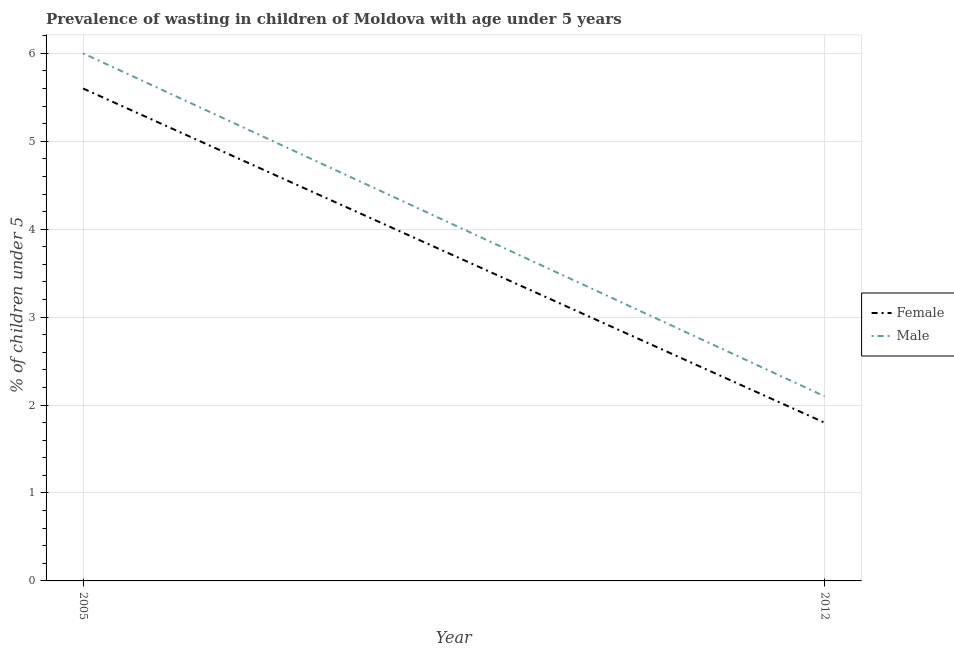Is the number of lines equal to the number of legend labels?
Offer a terse response. Yes. What is the percentage of undernourished female children in 2012?
Ensure brevity in your answer.  1.8. Across all years, what is the maximum percentage of undernourished female children?
Your answer should be compact. 5.6. Across all years, what is the minimum percentage of undernourished female children?
Your answer should be compact. 1.8. In which year was the percentage of undernourished female children maximum?
Make the answer very short. 2005. In which year was the percentage of undernourished male children minimum?
Your answer should be very brief. 2012. What is the total percentage of undernourished male children in the graph?
Give a very brief answer. 8.1. What is the difference between the percentage of undernourished male children in 2005 and that in 2012?
Keep it short and to the point. 3.9. What is the difference between the percentage of undernourished female children in 2005 and the percentage of undernourished male children in 2012?
Provide a succinct answer. 3.5. What is the average percentage of undernourished male children per year?
Ensure brevity in your answer.  4.05. In the year 2005, what is the difference between the percentage of undernourished male children and percentage of undernourished female children?
Keep it short and to the point. 0.4. In how many years, is the percentage of undernourished female children greater than 0.8 %?
Keep it short and to the point. 2. What is the ratio of the percentage of undernourished male children in 2005 to that in 2012?
Your answer should be compact. 2.86. Is the percentage of undernourished male children in 2005 less than that in 2012?
Your answer should be very brief. No. In how many years, is the percentage of undernourished female children greater than the average percentage of undernourished female children taken over all years?
Ensure brevity in your answer.  1. Is the percentage of undernourished female children strictly less than the percentage of undernourished male children over the years?
Your response must be concise. Yes. How many years are there in the graph?
Your answer should be very brief. 2. What is the difference between two consecutive major ticks on the Y-axis?
Make the answer very short. 1. Are the values on the major ticks of Y-axis written in scientific E-notation?
Keep it short and to the point. No. Does the graph contain any zero values?
Your answer should be very brief. No. Where does the legend appear in the graph?
Make the answer very short. Center right. How many legend labels are there?
Your response must be concise. 2. How are the legend labels stacked?
Your answer should be compact. Vertical. What is the title of the graph?
Offer a terse response. Prevalence of wasting in children of Moldova with age under 5 years. What is the label or title of the X-axis?
Make the answer very short. Year. What is the label or title of the Y-axis?
Your answer should be compact.  % of children under 5. What is the  % of children under 5 in Female in 2005?
Give a very brief answer. 5.6. What is the  % of children under 5 of Female in 2012?
Offer a very short reply. 1.8. What is the  % of children under 5 in Male in 2012?
Offer a terse response. 2.1. Across all years, what is the maximum  % of children under 5 of Female?
Ensure brevity in your answer.  5.6. Across all years, what is the maximum  % of children under 5 of Male?
Your response must be concise. 6. Across all years, what is the minimum  % of children under 5 of Female?
Give a very brief answer. 1.8. Across all years, what is the minimum  % of children under 5 of Male?
Offer a very short reply. 2.1. What is the total  % of children under 5 of Male in the graph?
Your answer should be compact. 8.1. What is the difference between the  % of children under 5 in Female in 2005 and that in 2012?
Your response must be concise. 3.8. What is the difference between the  % of children under 5 of Female in 2005 and the  % of children under 5 of Male in 2012?
Keep it short and to the point. 3.5. What is the average  % of children under 5 of Female per year?
Provide a short and direct response. 3.7. What is the average  % of children under 5 of Male per year?
Provide a succinct answer. 4.05. What is the ratio of the  % of children under 5 in Female in 2005 to that in 2012?
Your answer should be very brief. 3.11. What is the ratio of the  % of children under 5 in Male in 2005 to that in 2012?
Make the answer very short. 2.86. What is the difference between the highest and the second highest  % of children under 5 of Female?
Keep it short and to the point. 3.8. What is the difference between the highest and the second highest  % of children under 5 of Male?
Your answer should be compact. 3.9. What is the difference between the highest and the lowest  % of children under 5 of Female?
Offer a terse response. 3.8. What is the difference between the highest and the lowest  % of children under 5 of Male?
Keep it short and to the point. 3.9. 